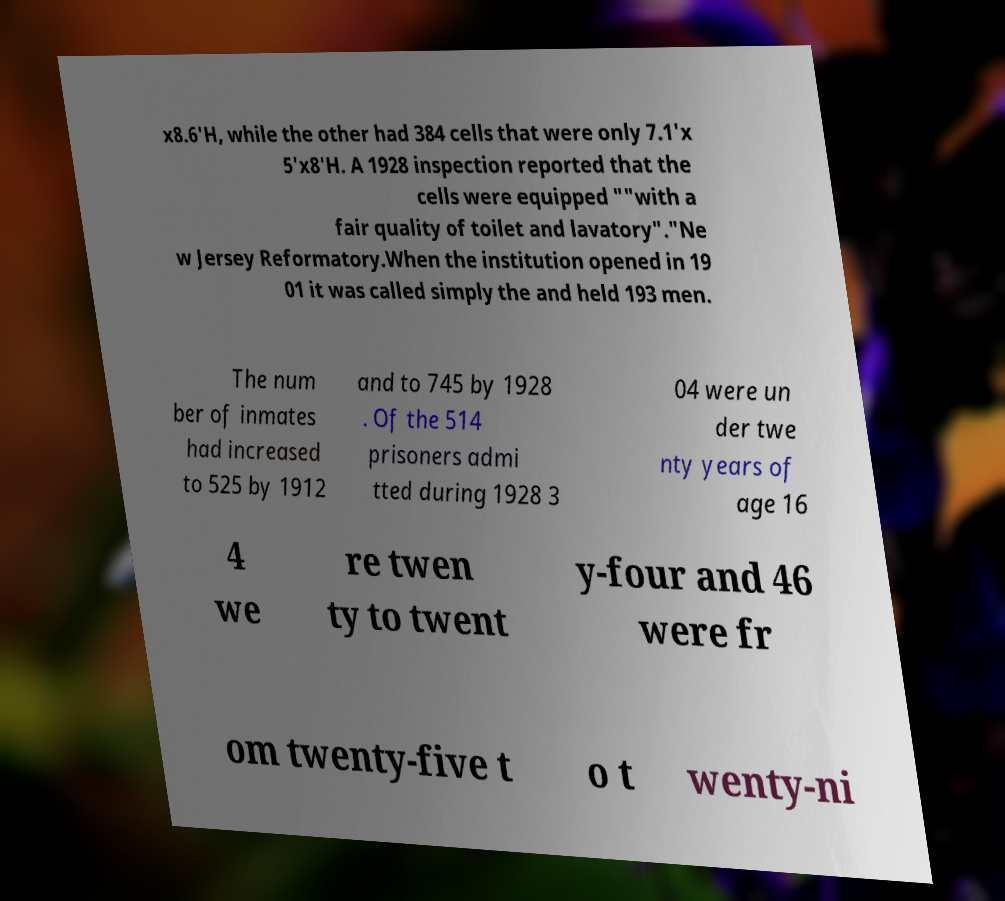Can you accurately transcribe the text from the provided image for me? x8.6'H, while the other had 384 cells that were only 7.1'x 5'x8'H. A 1928 inspection reported that the cells were equipped ""with a fair quality of toilet and lavatory"."Ne w Jersey Reformatory.When the institution opened in 19 01 it was called simply the and held 193 men. The num ber of inmates had increased to 525 by 1912 and to 745 by 1928 . Of the 514 prisoners admi tted during 1928 3 04 were un der twe nty years of age 16 4 we re twen ty to twent y-four and 46 were fr om twenty-five t o t wenty-ni 